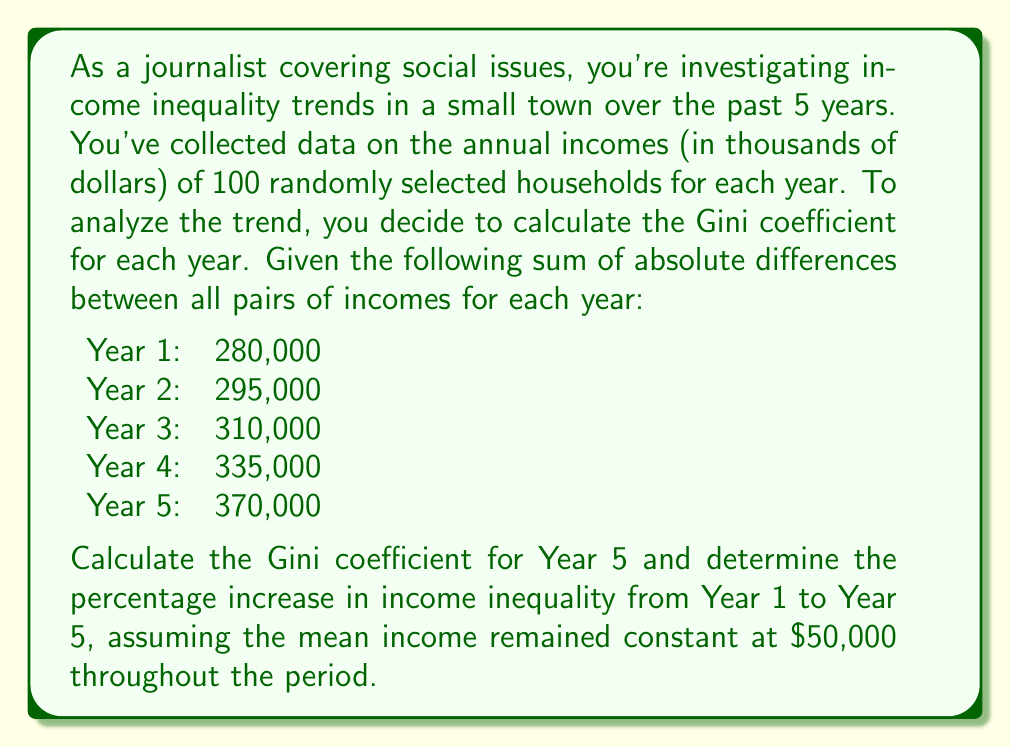Give your solution to this math problem. To solve this problem, we'll follow these steps:

1. Calculate the Gini coefficient for Year 5
2. Calculate the Gini coefficient for Year 1
3. Determine the percentage increase in income inequality

Step 1: Calculate the Gini coefficient for Year 5

The Gini coefficient is given by the formula:

$$ G = \frac{\sum_{i=1}^n \sum_{j=1}^n |x_i - x_j|}{2n^2\mu} $$

Where:
- $\sum_{i=1}^n \sum_{j=1}^n |x_i - x_j|$ is the sum of absolute differences between all pairs of incomes
- $n$ is the number of households
- $\mu$ is the mean income

For Year 5:
- Sum of absolute differences = 370,000
- n = 100
- μ = $50,000

Plugging these values into the formula:

$$ G_{Year 5} = \frac{370,000}{2 \cdot 100^2 \cdot 50,000} = \frac{370,000}{1,000,000} = 0.37 $$

Step 2: Calculate the Gini coefficient for Year 1

Using the same formula with Year 1 data:

$$ G_{Year 1} = \frac{280,000}{2 \cdot 100^2 \cdot 50,000} = \frac{280,000}{1,000,000} = 0.28 $$

Step 3: Determine the percentage increase in income inequality

To calculate the percentage increase, we use the formula:

$$ \text{Percentage Increase} = \frac{\text{New Value} - \text{Original Value}}{\text{Original Value}} \times 100\% $$

Plugging in our Gini coefficients:

$$ \text{Percentage Increase} = \frac{0.37 - 0.28}{0.28} \times 100\% = \frac{0.09}{0.28} \times 100\% = 32.14\% $$
Answer: The Gini coefficient for Year 5 is 0.37, and the percentage increase in income inequality from Year 1 to Year 5 is 32.14%. 